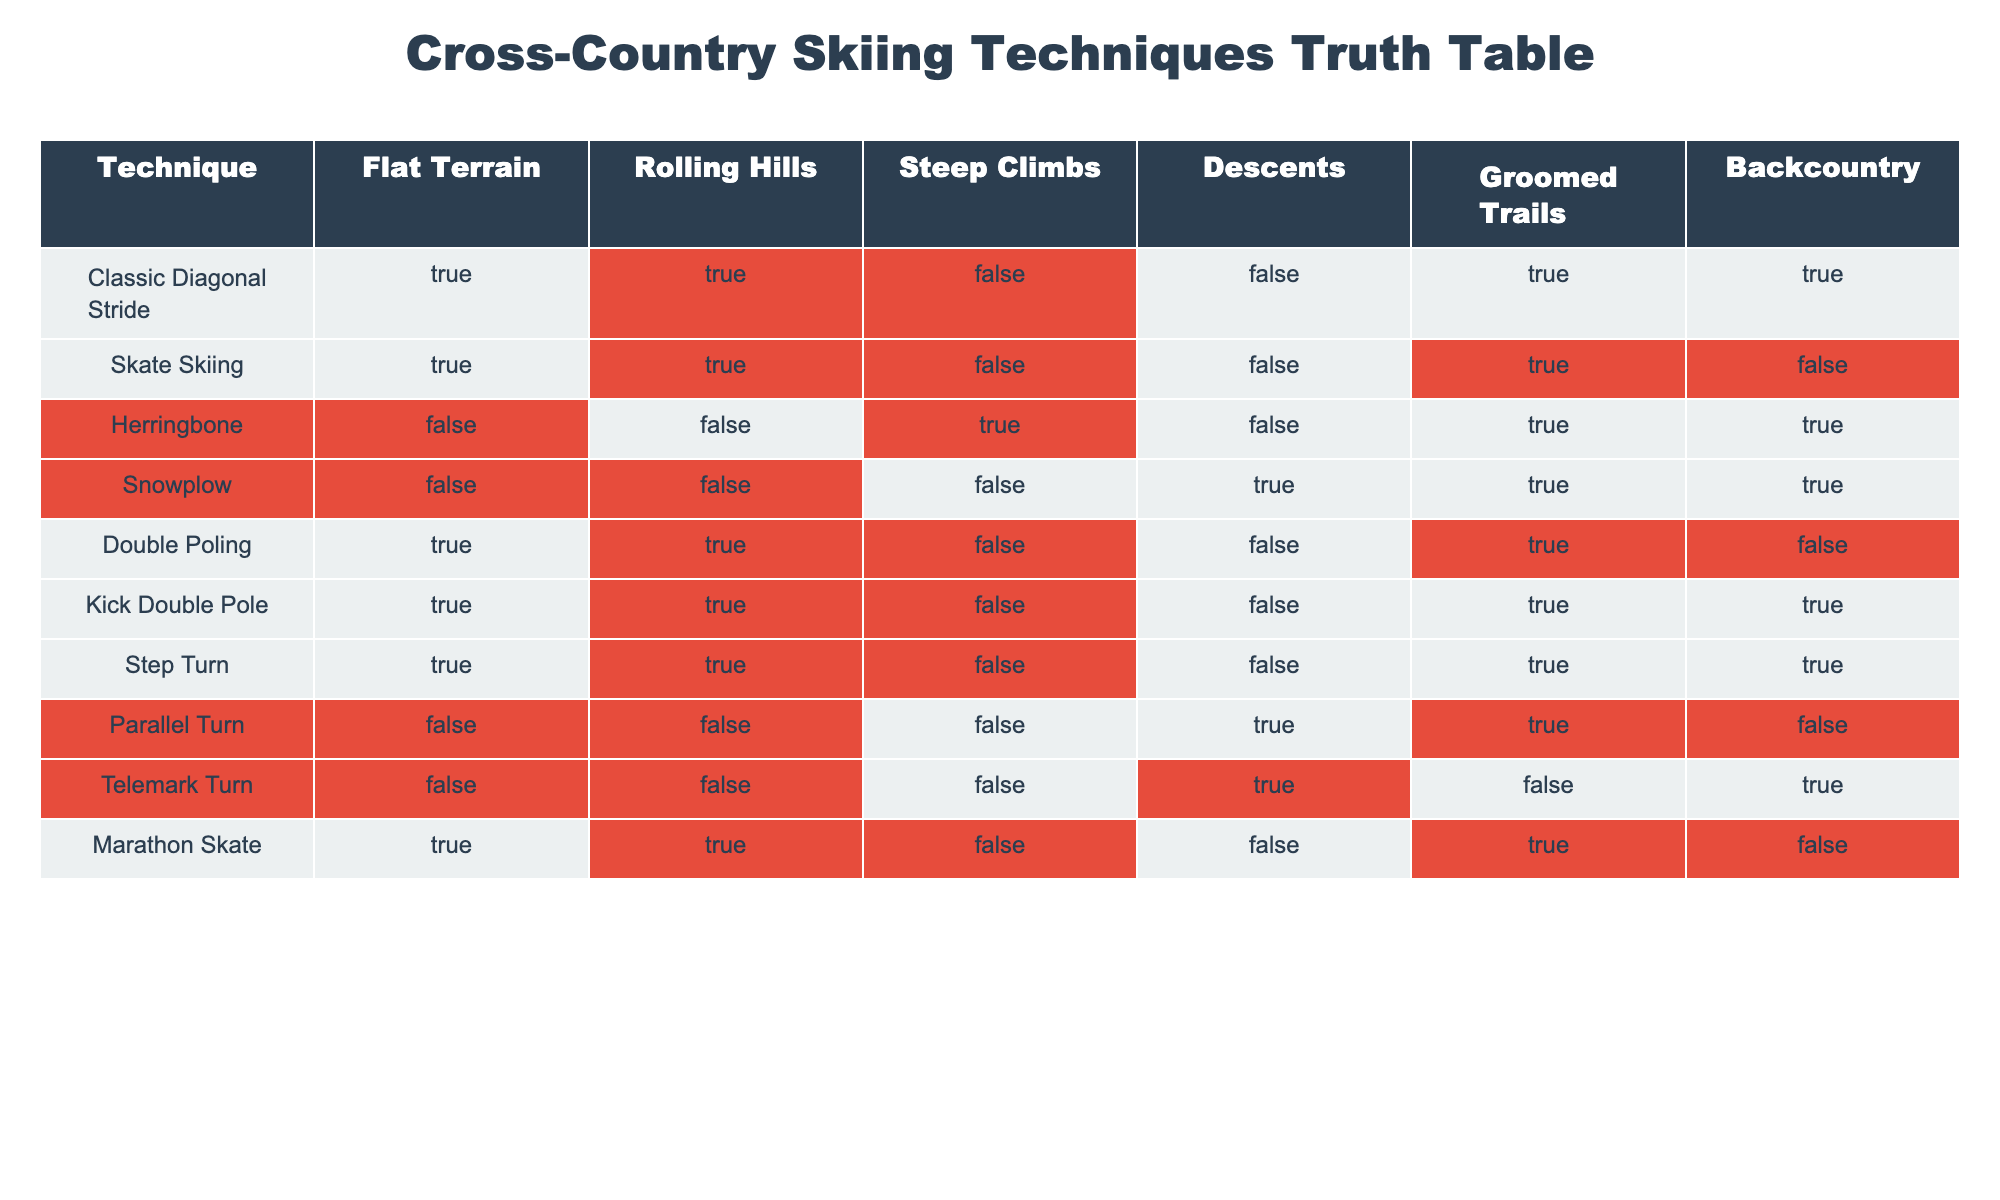What cross-country skiing technique is suitable for steep climbs? According to the table, the only technique marked as true for steep climbs is Herringbone.
Answer: Herringbone Which techniques can be used on both groomed trails and backcountry? By looking at the table, the techniques that are true for both groomed trails and backcountry are Classic Diagonal Stride, Snowplow, Kick Double Pole, and Herringbone.
Answer: Classic Diagonal Stride, Snowplow, Kick Double Pole, Herringbone Is the Parallel Turn technique suitable for flat terrain? The table shows that Parallel Turn is marked as false for flat terrain.
Answer: No Which technique has the most true values overall across all terrain types? After analyzing the table, the Classic Diagonal Stride has true values for five terrain types (Flat Terrain, Rolling Hills, Groomed Trails, Backcountry). Other techniques have fewer true values.
Answer: Classic Diagonal Stride What is the total number of techniques that are suitable for both descents and groomed trails? The table indicates the techniques suitable for both descents and groomed trails are Snowplow and Parallel Turn, totaling 2 techniques.
Answer: 2 Is the Kick Double Pole technique effective for backcountry skiing? The table shows that Kick Double Pole is marked as true for backcountry, indicating its effectiveness in that terrain.
Answer: Yes How many techniques can be used on rolling hills but not on steep climbs? Evaluating the table, the techniques suitable for rolling hills (Classic Diagonal Stride, Skate Skiing, Double Poling, Kick Double Pole, Step Turn, Marathon Skate) but not for steep climbs are six in total.
Answer: 6 Does the technique Marathon Skate work for both flat terrain and descents? The table shows that Marathon Skate is marked as true for flat terrain but false for descents.
Answer: No 